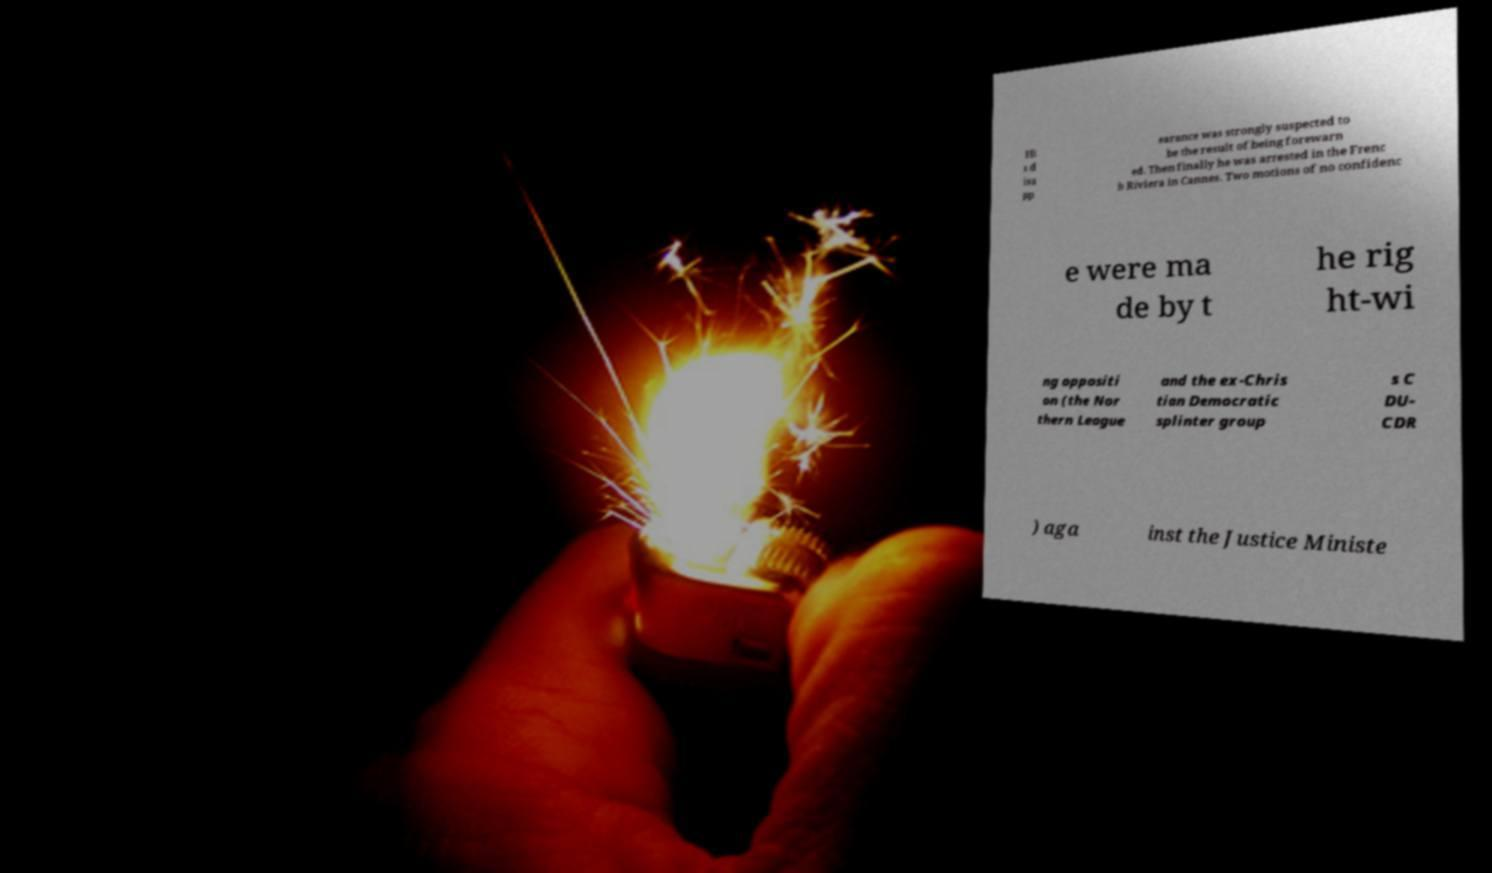What messages or text are displayed in this image? I need them in a readable, typed format. Hi s d isa pp earance was strongly suspected to be the result of being forewarn ed. Then finally he was arrested in the Frenc h Riviera in Cannes. Two motions of no confidenc e were ma de by t he rig ht-wi ng oppositi on (the Nor thern League and the ex-Chris tian Democratic splinter group s C DU- CDR ) aga inst the Justice Ministe 